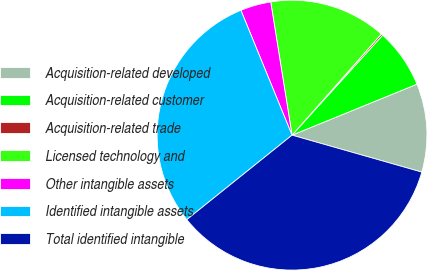Convert chart. <chart><loc_0><loc_0><loc_500><loc_500><pie_chart><fcel>Acquisition-related developed<fcel>Acquisition-related customer<fcel>Acquisition-related trade<fcel>Licensed technology and<fcel>Other intangible assets<fcel>Identified intangible assets<fcel>Total identified intangible<nl><fcel>10.58%<fcel>7.12%<fcel>0.2%<fcel>14.04%<fcel>3.66%<fcel>29.58%<fcel>34.82%<nl></chart> 